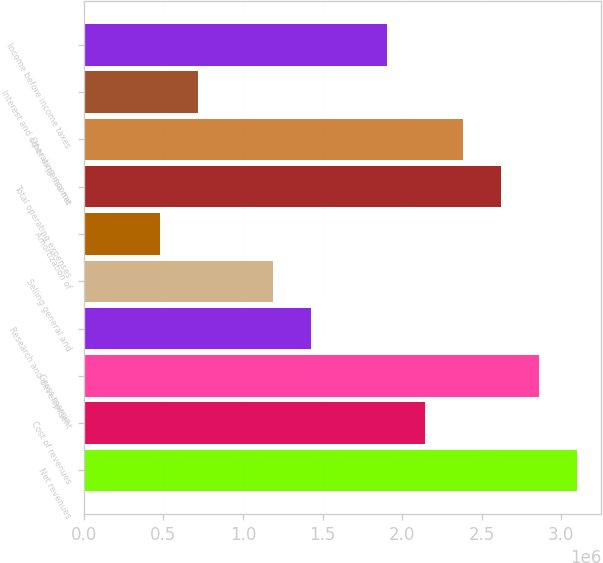<chart> <loc_0><loc_0><loc_500><loc_500><bar_chart><fcel>Net revenues<fcel>Cost of revenues<fcel>Gross margin<fcel>Research and development<fcel>Selling general and<fcel>Amortization of<fcel>Total operating expenses<fcel>Operating income<fcel>Interest and other expense net<fcel>Income before income taxes<nl><fcel>3.09729e+06<fcel>2.14428e+06<fcel>2.85904e+06<fcel>1.42952e+06<fcel>1.19127e+06<fcel>476508<fcel>2.62078e+06<fcel>2.38253e+06<fcel>714761<fcel>1.90603e+06<nl></chart> 